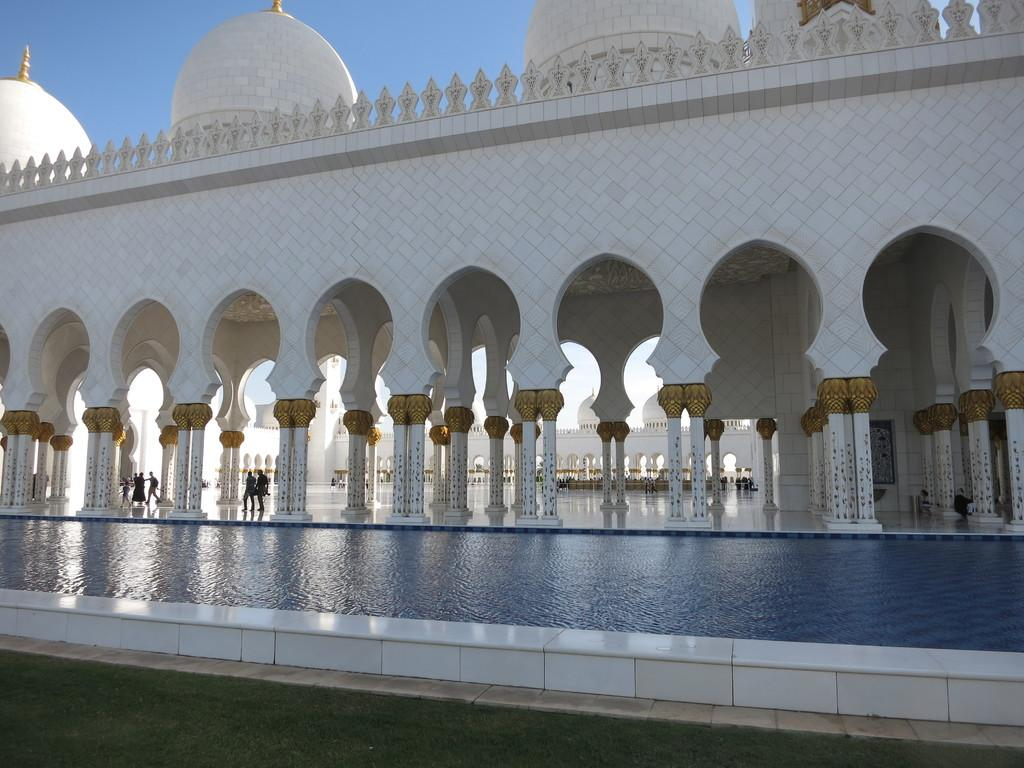What type of terrain is visible in the image? There is grass in the image. What else can be seen in the image besides grass? There is water and white-colored buildings visible in the image. Are there any people present in the image? Yes, there are people in the image. What is visible in the background of the image? The sky is visible in the background of the image. What type of story is being told by the chicken in the image? There is no chicken present in the image, so no story can be told by a chicken. 